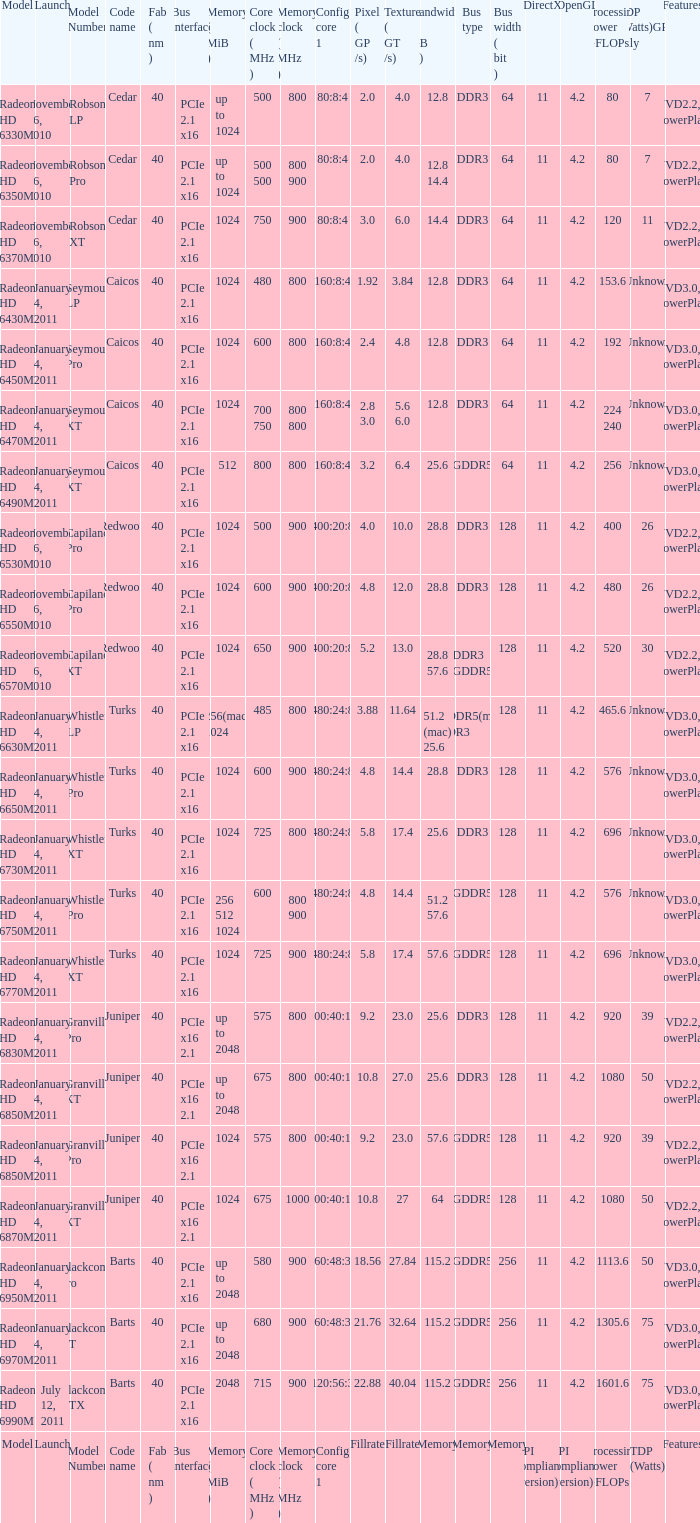What is every bus type for the texture of fillrate? Memory. 